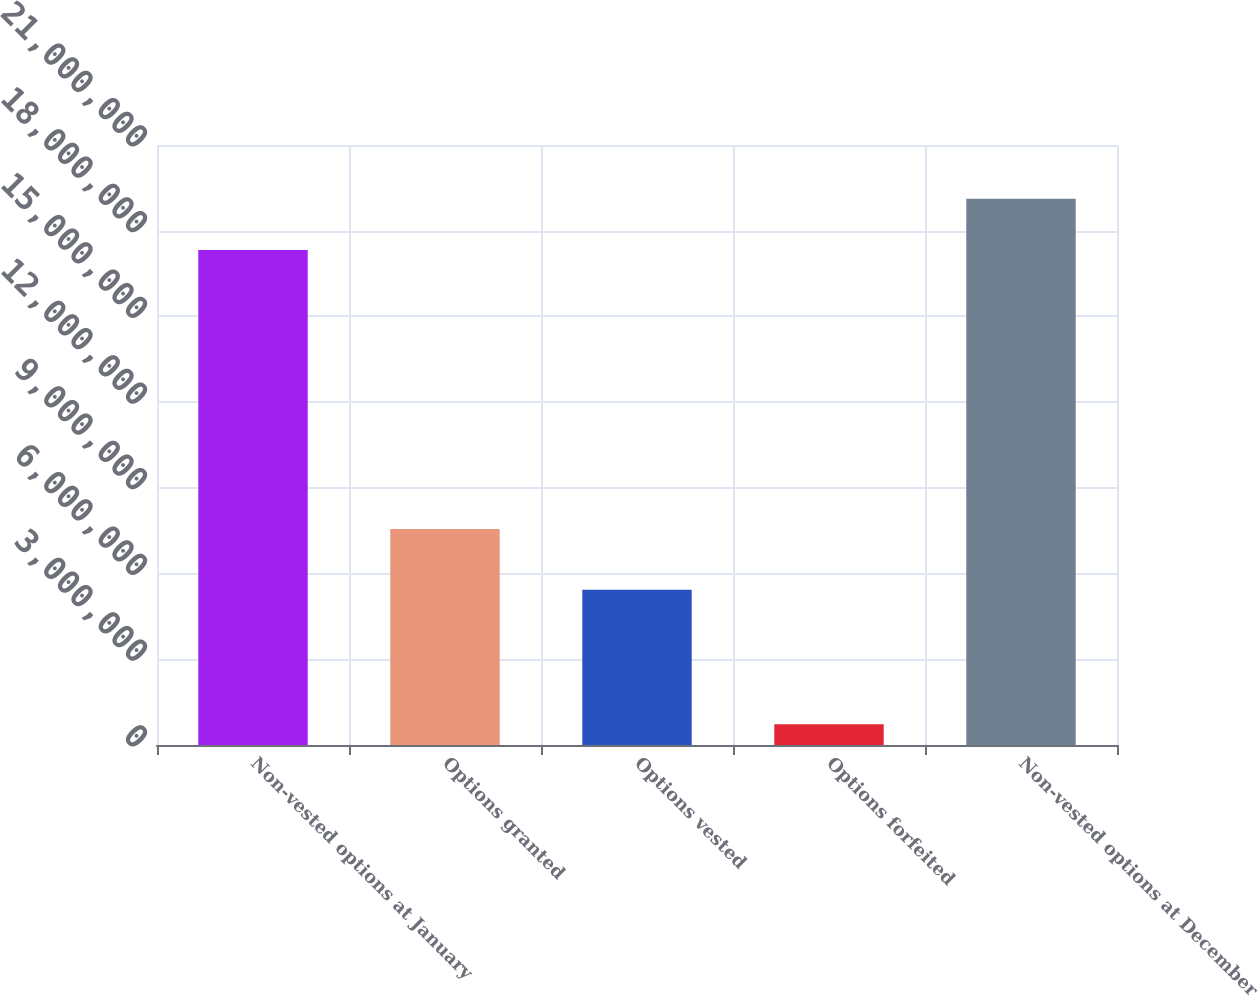Convert chart. <chart><loc_0><loc_0><loc_500><loc_500><bar_chart><fcel>Non-vested options at January<fcel>Options granted<fcel>Options vested<fcel>Options forfeited<fcel>Non-vested options at December<nl><fcel>1.7323e+07<fcel>7.56045e+06<fcel>5.43064e+06<fcel>727280<fcel>1.91229e+07<nl></chart> 